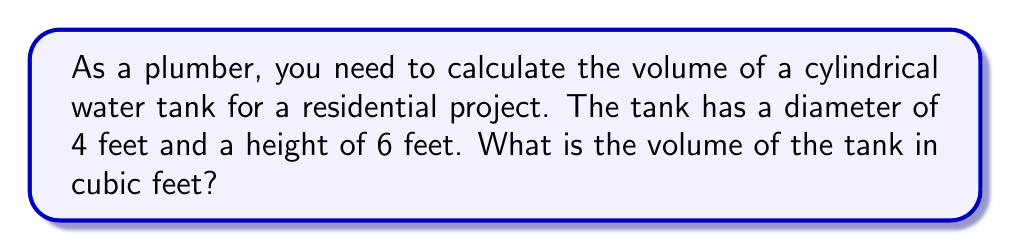Give your solution to this math problem. To find the volume of a cylindrical container, we use the formula:

$$V = \pi r^2 h$$

Where:
$V$ = volume
$r$ = radius of the base
$h$ = height of the cylinder

Step 1: Determine the radius
The diameter is 4 feet, so the radius is half of that:
$r = 4 \div 2 = 2$ feet

Step 2: Apply the formula
$$\begin{align*}
V &= \pi r^2 h \\
&= \pi \cdot (2\text{ ft})^2 \cdot 6\text{ ft} \\
&= \pi \cdot 4\text{ ft}^2 \cdot 6\text{ ft} \\
&= 24\pi\text{ ft}^3
\end{align*}$$

Step 3: Calculate the final value
$24\pi \approx 75.40$ cubic feet

Therefore, the volume of the cylindrical water tank is approximately 75.40 cubic feet.
Answer: $75.40\text{ ft}^3$ 